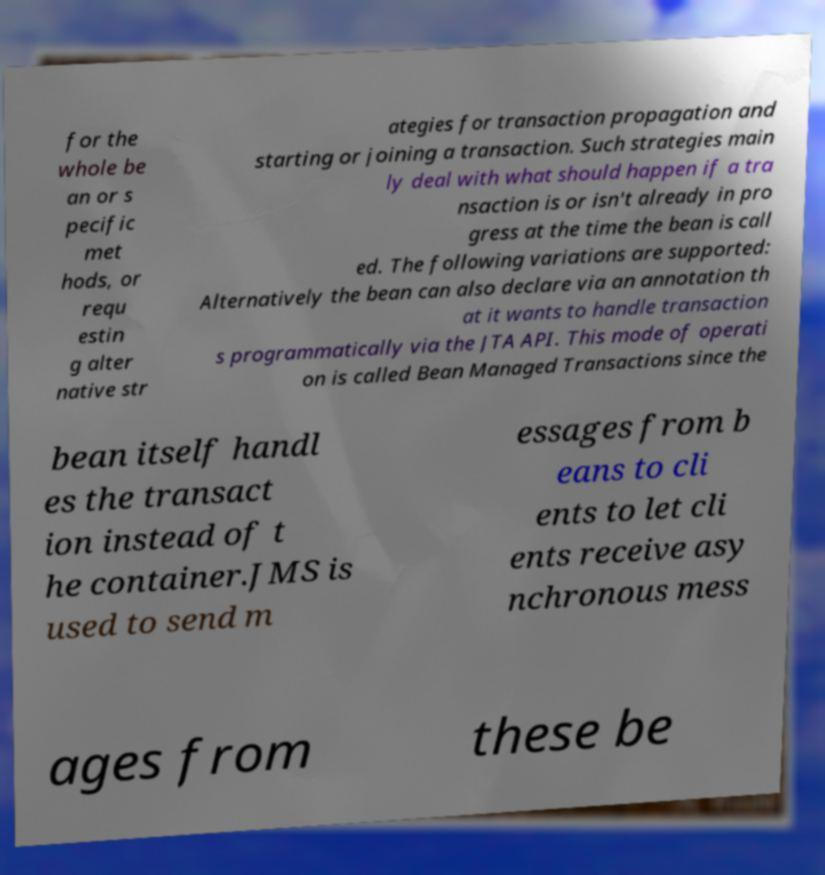For documentation purposes, I need the text within this image transcribed. Could you provide that? for the whole be an or s pecific met hods, or requ estin g alter native str ategies for transaction propagation and starting or joining a transaction. Such strategies main ly deal with what should happen if a tra nsaction is or isn't already in pro gress at the time the bean is call ed. The following variations are supported: Alternatively the bean can also declare via an annotation th at it wants to handle transaction s programmatically via the JTA API. This mode of operati on is called Bean Managed Transactions since the bean itself handl es the transact ion instead of t he container.JMS is used to send m essages from b eans to cli ents to let cli ents receive asy nchronous mess ages from these be 